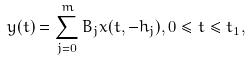Convert formula to latex. <formula><loc_0><loc_0><loc_500><loc_500>y ( t ) = \sum _ { j = 0 } ^ { m } B _ { j } x ( t , - h _ { j } ) , 0 \leq t \leq t _ { 1 } ,</formula> 